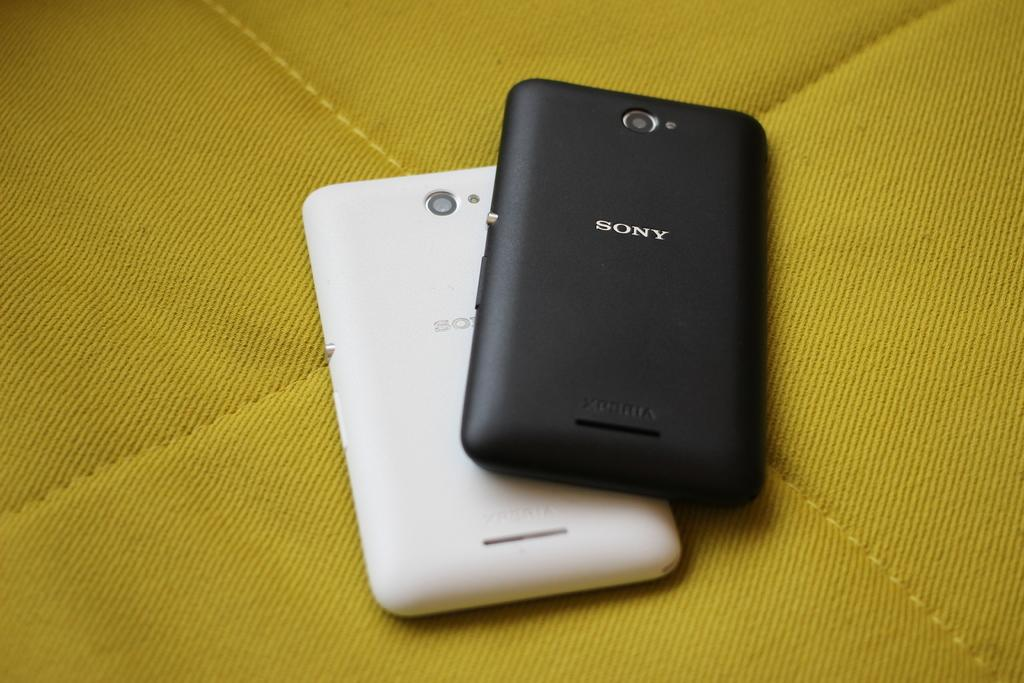How many mobiles are visible in the image? There are two mobiles in the image. What is the color of the mobile on the left side? The mobile on the left side is white. What is the color of the mobile on the right side? The mobile on the right side is black. What level of difficulty does the beginner face when trying to cover the can with the mobiles? There is no mention of a beginner, difficulty level, or covering a can with the mobiles. This scenario is not present in the image. 